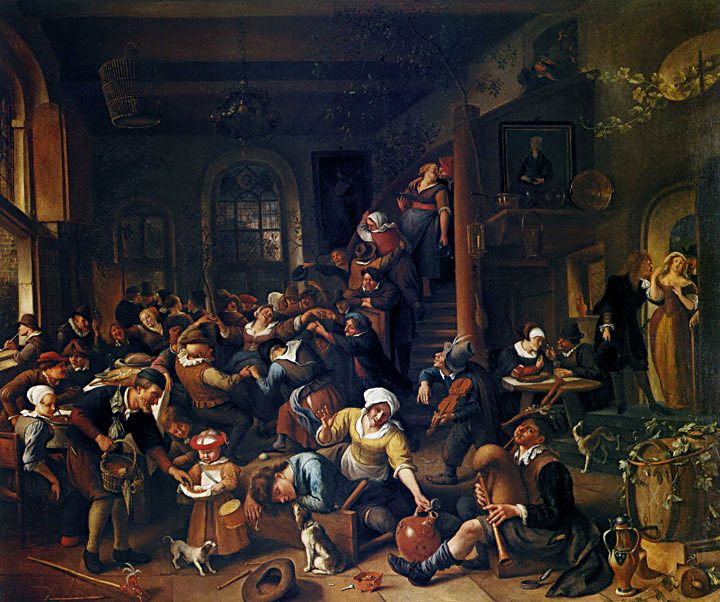Can you tell me more about the painting on the wall in the background? The painting on the back wall is partially obscured, but it seems to depict a religious or mythological scene, which contrasts with the secular, lively tavern setting of the main painting. This juxtaposition may hint at moral lessons or serve to reflect societal norms and behaviours through the contrast of sacred and profane themes. Does this imply any criticism by the artist? Potentially, yes. By placing a religious or moral painting within a scene of debauchery, the artist might be critiquing societal hypocrisy or warning against overindulgence, a common theme in Baroque art which often explored the moral undertones of daily life through vivid and dramatic portrayal. 